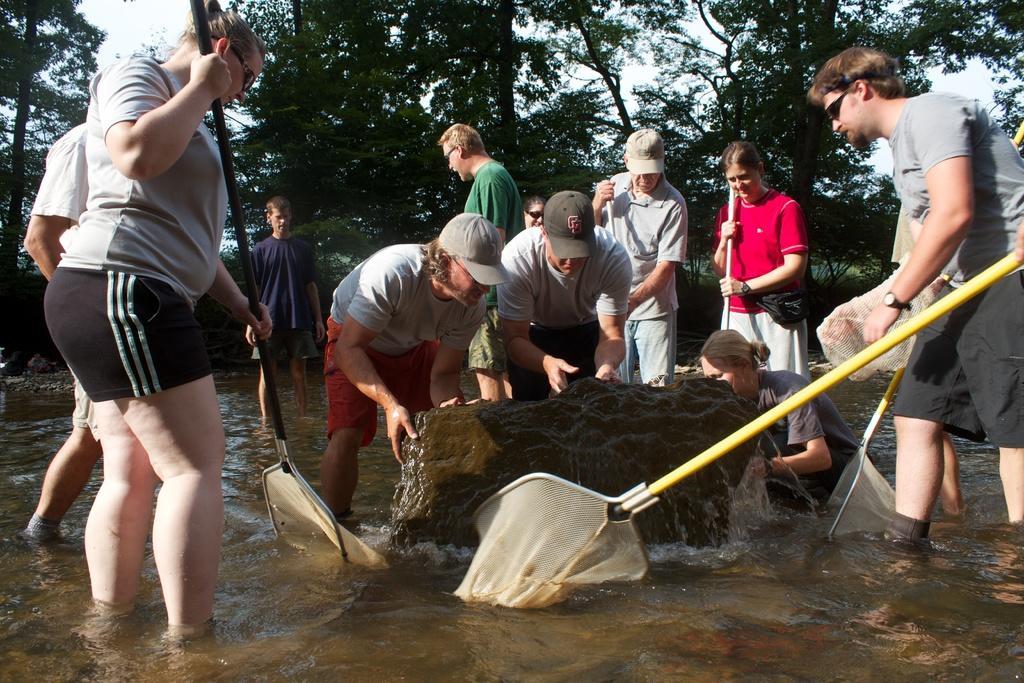In one or two sentences, can you explain what this image depicts? In this picture there are group of people standing and few are holding the objects. In the middle of the image it looks like a stone. At the back there are trees. At the top there is sky. At the bottom there is water. 